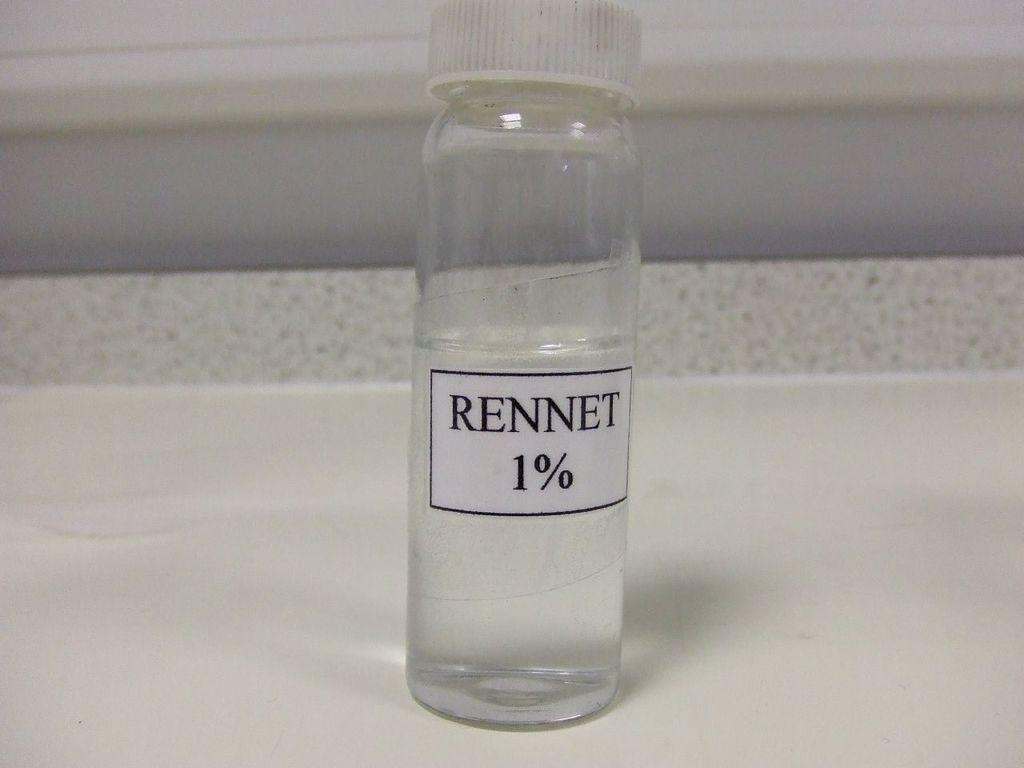<image>
Provide a brief description of the given image. a bottle with the word Rennet on it 